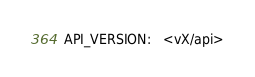Convert code to text. <code><loc_0><loc_0><loc_500><loc_500><_YAML_>API_VERSION:   <vX/api>
</code> 